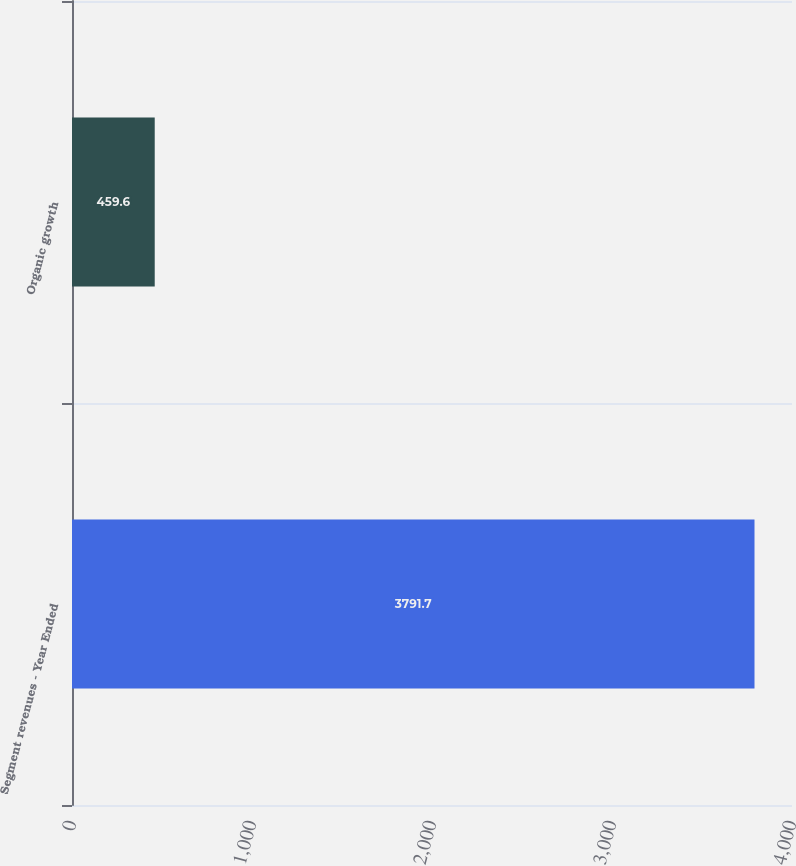<chart> <loc_0><loc_0><loc_500><loc_500><bar_chart><fcel>Segment revenues - Year Ended<fcel>Organic growth<nl><fcel>3791.7<fcel>459.6<nl></chart> 